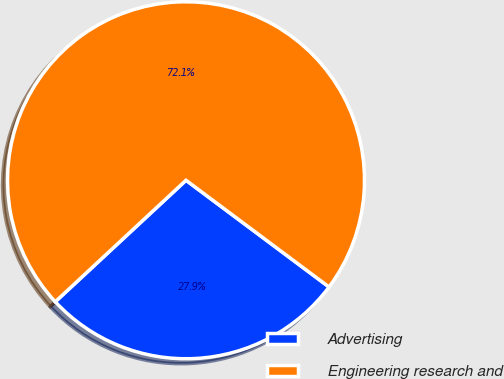<chart> <loc_0><loc_0><loc_500><loc_500><pie_chart><fcel>Advertising<fcel>Engineering research and<nl><fcel>27.88%<fcel>72.12%<nl></chart> 